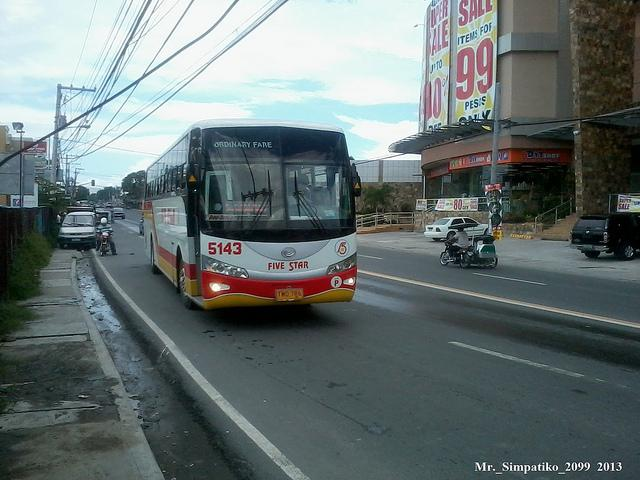What type of sign is on the building? Please explain your reasoning. informational. The sign mentions sale prices and other information. 